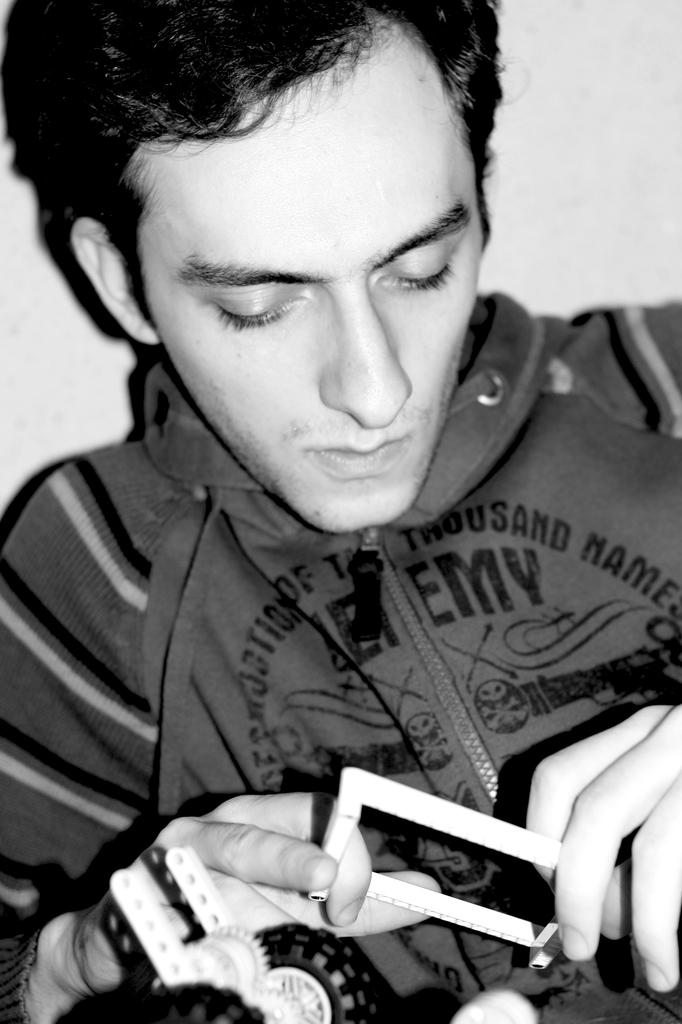What is the color scheme of the image? The image is black and white. Can you describe the main subject in the image? There is a person in the image. What is the person doing in the image? The person is holding something. What type of cloth is draped over the truck in the image? There is no truck or cloth present in the image. What kind of food is the person eating in the image? There is no food visible in the image; the person is holding something, but it is not specified as food. 